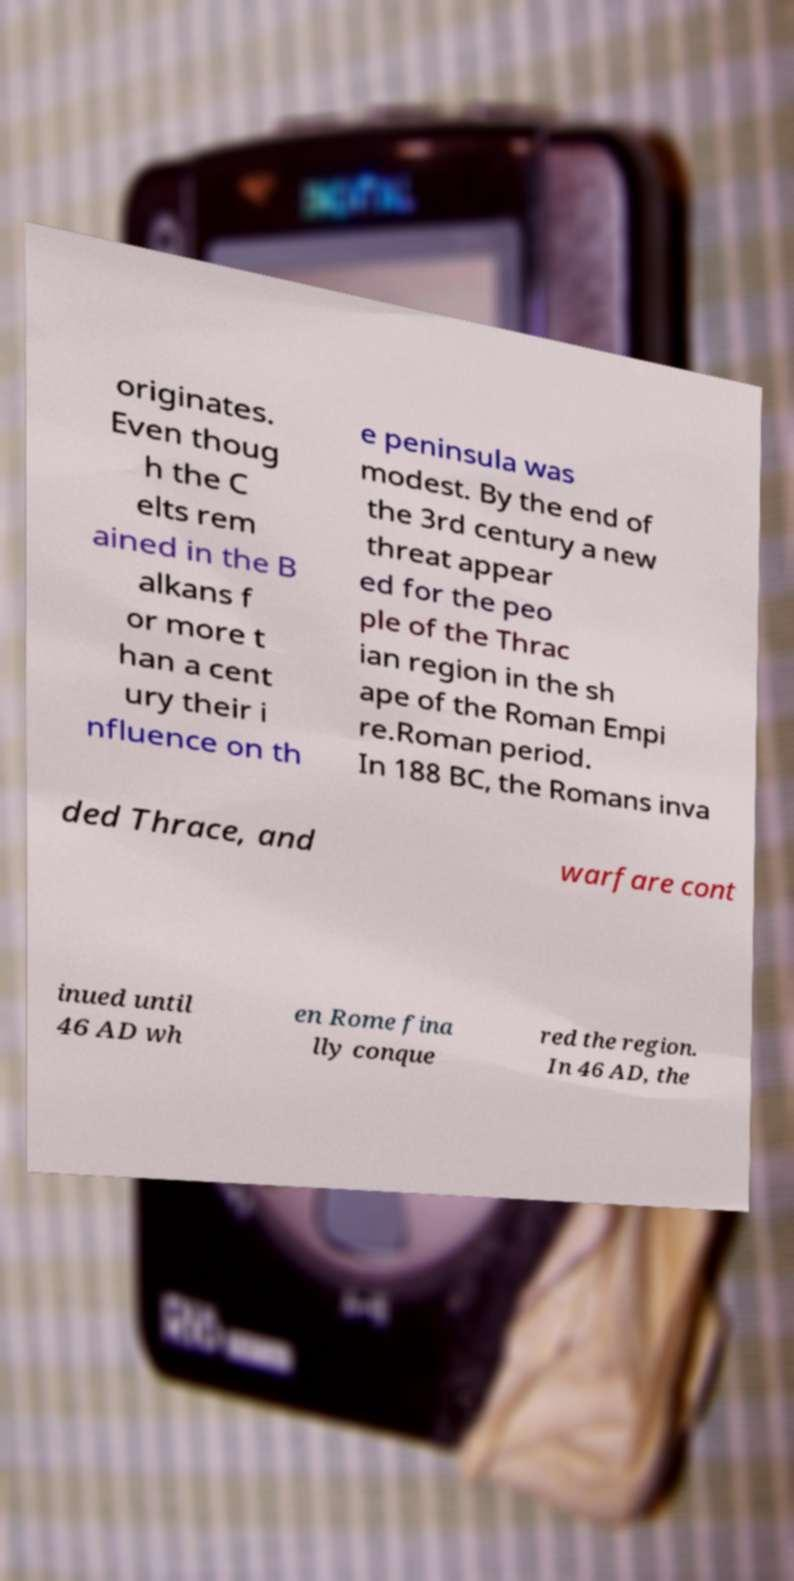There's text embedded in this image that I need extracted. Can you transcribe it verbatim? originates. Even thoug h the C elts rem ained in the B alkans f or more t han a cent ury their i nfluence on th e peninsula was modest. By the end of the 3rd century a new threat appear ed for the peo ple of the Thrac ian region in the sh ape of the Roman Empi re.Roman period. In 188 BC, the Romans inva ded Thrace, and warfare cont inued until 46 AD wh en Rome fina lly conque red the region. In 46 AD, the 